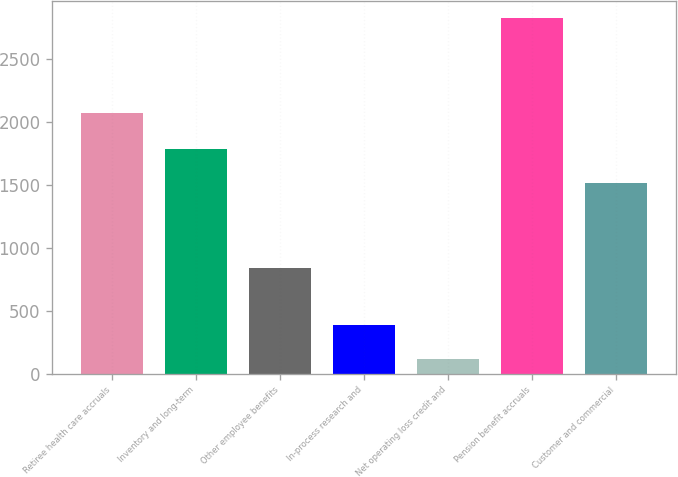Convert chart to OTSL. <chart><loc_0><loc_0><loc_500><loc_500><bar_chart><fcel>Retiree health care accruals<fcel>Inventory and long-term<fcel>Other employee benefits<fcel>In-process research and<fcel>Net operating loss credit and<fcel>Pension benefit accruals<fcel>Customer and commercial<nl><fcel>2073<fcel>1783.8<fcel>842<fcel>388.8<fcel>118<fcel>2826<fcel>1513<nl></chart> 